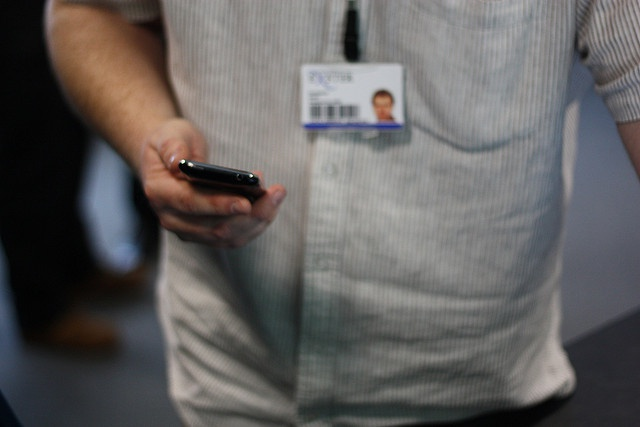Describe the objects in this image and their specific colors. I can see people in black, darkgray, and gray tones and cell phone in black, gray, and maroon tones in this image. 